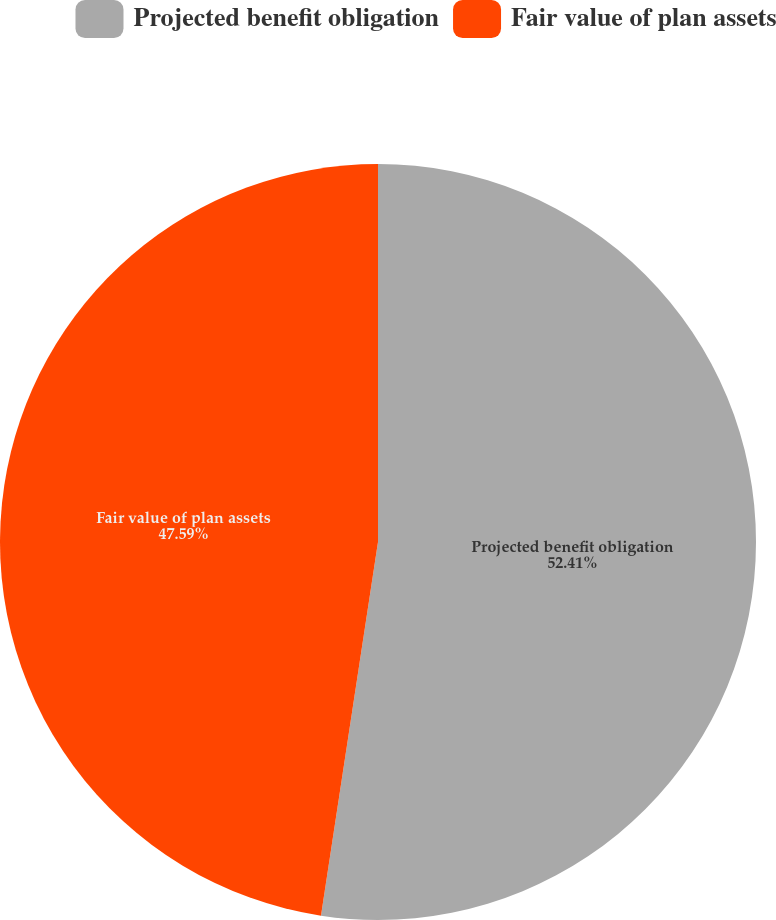Convert chart to OTSL. <chart><loc_0><loc_0><loc_500><loc_500><pie_chart><fcel>Projected benefit obligation<fcel>Fair value of plan assets<nl><fcel>52.41%<fcel>47.59%<nl></chart> 